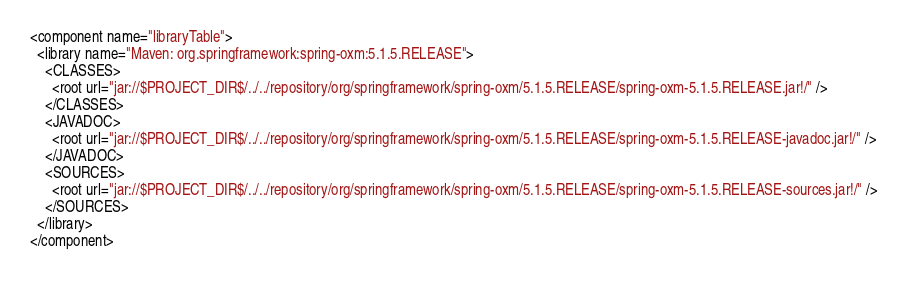<code> <loc_0><loc_0><loc_500><loc_500><_XML_><component name="libraryTable">
  <library name="Maven: org.springframework:spring-oxm:5.1.5.RELEASE">
    <CLASSES>
      <root url="jar://$PROJECT_DIR$/../../repository/org/springframework/spring-oxm/5.1.5.RELEASE/spring-oxm-5.1.5.RELEASE.jar!/" />
    </CLASSES>
    <JAVADOC>
      <root url="jar://$PROJECT_DIR$/../../repository/org/springframework/spring-oxm/5.1.5.RELEASE/spring-oxm-5.1.5.RELEASE-javadoc.jar!/" />
    </JAVADOC>
    <SOURCES>
      <root url="jar://$PROJECT_DIR$/../../repository/org/springframework/spring-oxm/5.1.5.RELEASE/spring-oxm-5.1.5.RELEASE-sources.jar!/" />
    </SOURCES>
  </library>
</component></code> 